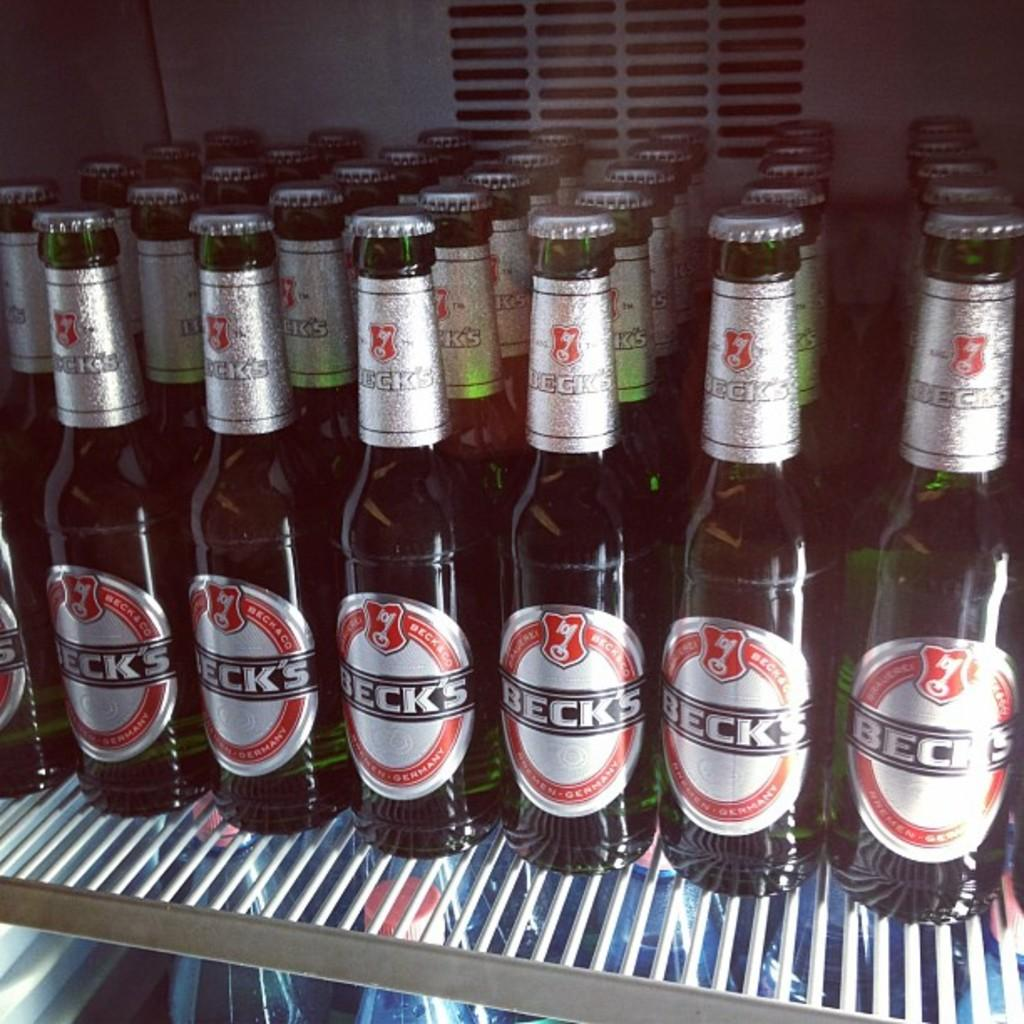<image>
Give a short and clear explanation of the subsequent image. A refrigerated cooler stocked with glass bottles of Beck's beer. 